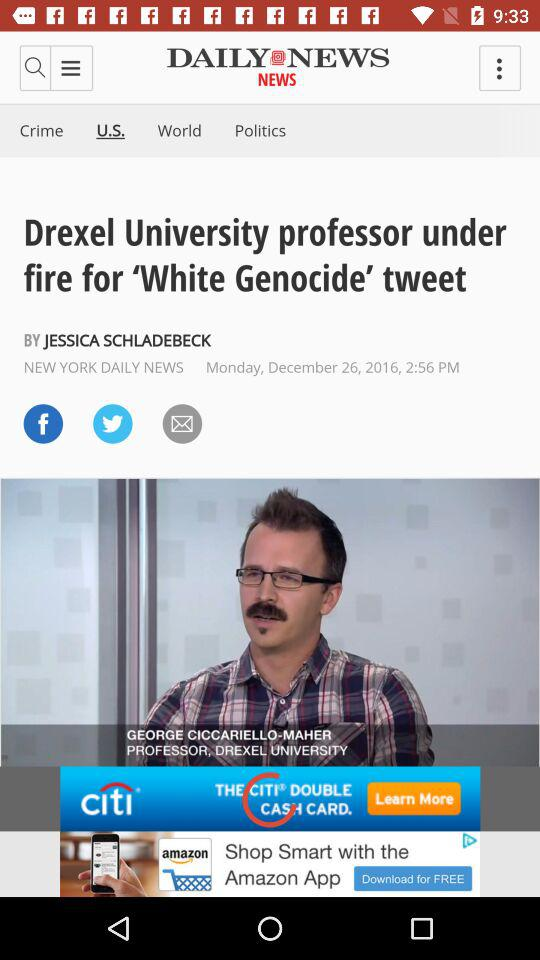Which tab is selected? The selected tab is "U.S.". 